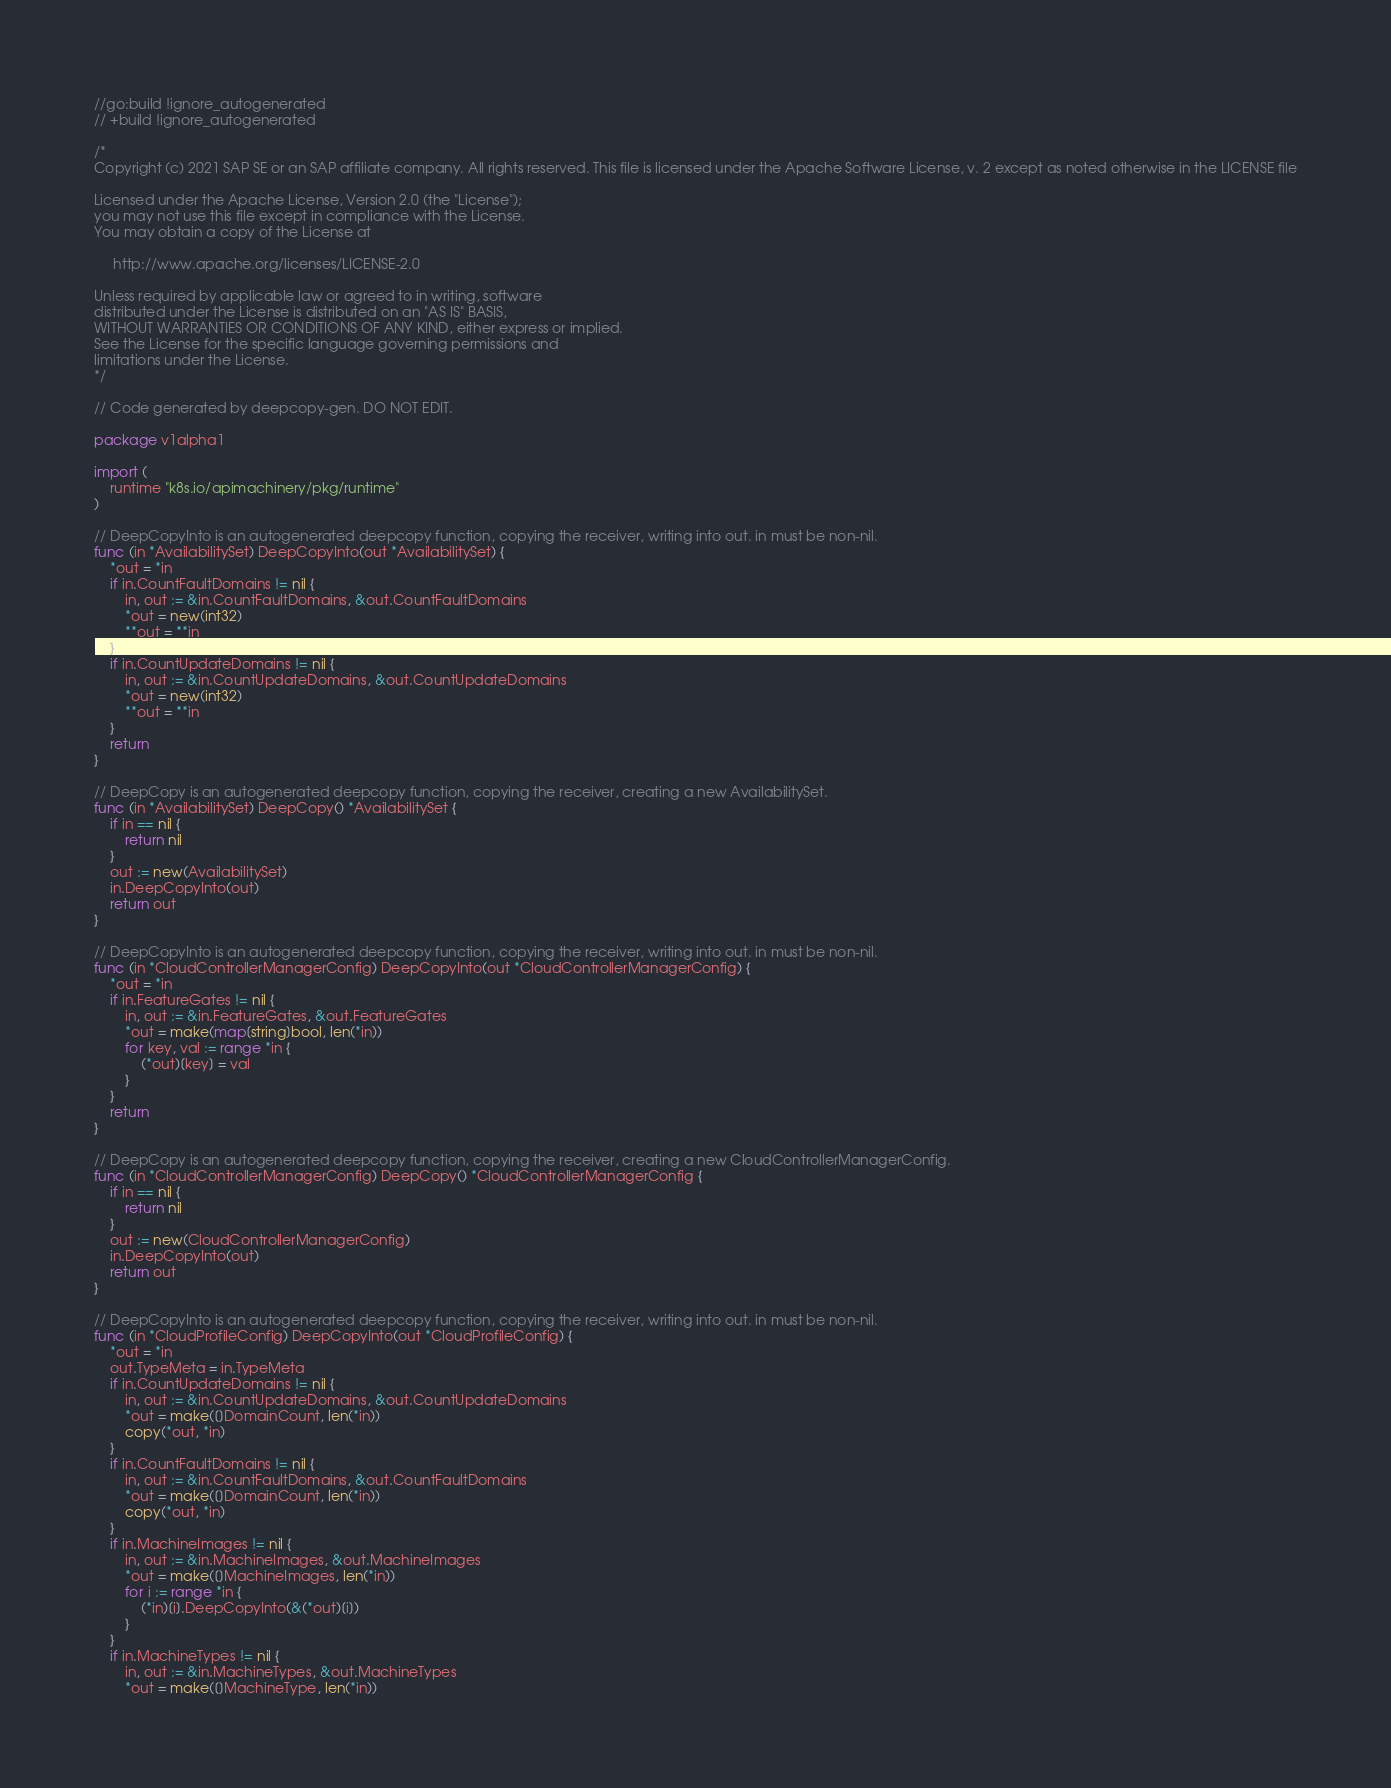<code> <loc_0><loc_0><loc_500><loc_500><_Go_>//go:build !ignore_autogenerated
// +build !ignore_autogenerated

/*
Copyright (c) 2021 SAP SE or an SAP affiliate company. All rights reserved. This file is licensed under the Apache Software License, v. 2 except as noted otherwise in the LICENSE file

Licensed under the Apache License, Version 2.0 (the "License");
you may not use this file except in compliance with the License.
You may obtain a copy of the License at

     http://www.apache.org/licenses/LICENSE-2.0

Unless required by applicable law or agreed to in writing, software
distributed under the License is distributed on an "AS IS" BASIS,
WITHOUT WARRANTIES OR CONDITIONS OF ANY KIND, either express or implied.
See the License for the specific language governing permissions and
limitations under the License.
*/

// Code generated by deepcopy-gen. DO NOT EDIT.

package v1alpha1

import (
	runtime "k8s.io/apimachinery/pkg/runtime"
)

// DeepCopyInto is an autogenerated deepcopy function, copying the receiver, writing into out. in must be non-nil.
func (in *AvailabilitySet) DeepCopyInto(out *AvailabilitySet) {
	*out = *in
	if in.CountFaultDomains != nil {
		in, out := &in.CountFaultDomains, &out.CountFaultDomains
		*out = new(int32)
		**out = **in
	}
	if in.CountUpdateDomains != nil {
		in, out := &in.CountUpdateDomains, &out.CountUpdateDomains
		*out = new(int32)
		**out = **in
	}
	return
}

// DeepCopy is an autogenerated deepcopy function, copying the receiver, creating a new AvailabilitySet.
func (in *AvailabilitySet) DeepCopy() *AvailabilitySet {
	if in == nil {
		return nil
	}
	out := new(AvailabilitySet)
	in.DeepCopyInto(out)
	return out
}

// DeepCopyInto is an autogenerated deepcopy function, copying the receiver, writing into out. in must be non-nil.
func (in *CloudControllerManagerConfig) DeepCopyInto(out *CloudControllerManagerConfig) {
	*out = *in
	if in.FeatureGates != nil {
		in, out := &in.FeatureGates, &out.FeatureGates
		*out = make(map[string]bool, len(*in))
		for key, val := range *in {
			(*out)[key] = val
		}
	}
	return
}

// DeepCopy is an autogenerated deepcopy function, copying the receiver, creating a new CloudControllerManagerConfig.
func (in *CloudControllerManagerConfig) DeepCopy() *CloudControllerManagerConfig {
	if in == nil {
		return nil
	}
	out := new(CloudControllerManagerConfig)
	in.DeepCopyInto(out)
	return out
}

// DeepCopyInto is an autogenerated deepcopy function, copying the receiver, writing into out. in must be non-nil.
func (in *CloudProfileConfig) DeepCopyInto(out *CloudProfileConfig) {
	*out = *in
	out.TypeMeta = in.TypeMeta
	if in.CountUpdateDomains != nil {
		in, out := &in.CountUpdateDomains, &out.CountUpdateDomains
		*out = make([]DomainCount, len(*in))
		copy(*out, *in)
	}
	if in.CountFaultDomains != nil {
		in, out := &in.CountFaultDomains, &out.CountFaultDomains
		*out = make([]DomainCount, len(*in))
		copy(*out, *in)
	}
	if in.MachineImages != nil {
		in, out := &in.MachineImages, &out.MachineImages
		*out = make([]MachineImages, len(*in))
		for i := range *in {
			(*in)[i].DeepCopyInto(&(*out)[i])
		}
	}
	if in.MachineTypes != nil {
		in, out := &in.MachineTypes, &out.MachineTypes
		*out = make([]MachineType, len(*in))</code> 